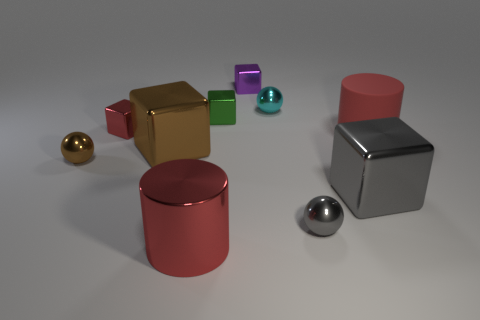Subtract 2 blocks. How many blocks are left? 3 Subtract all gray cubes. How many cubes are left? 4 Subtract all gray cubes. How many cubes are left? 4 Subtract all red blocks. Subtract all gray balls. How many blocks are left? 4 Subtract all spheres. How many objects are left? 7 Subtract 0 yellow cylinders. How many objects are left? 10 Subtract all brown blocks. Subtract all tiny green things. How many objects are left? 8 Add 4 small green metallic objects. How many small green metallic objects are left? 5 Add 5 big cylinders. How many big cylinders exist? 7 